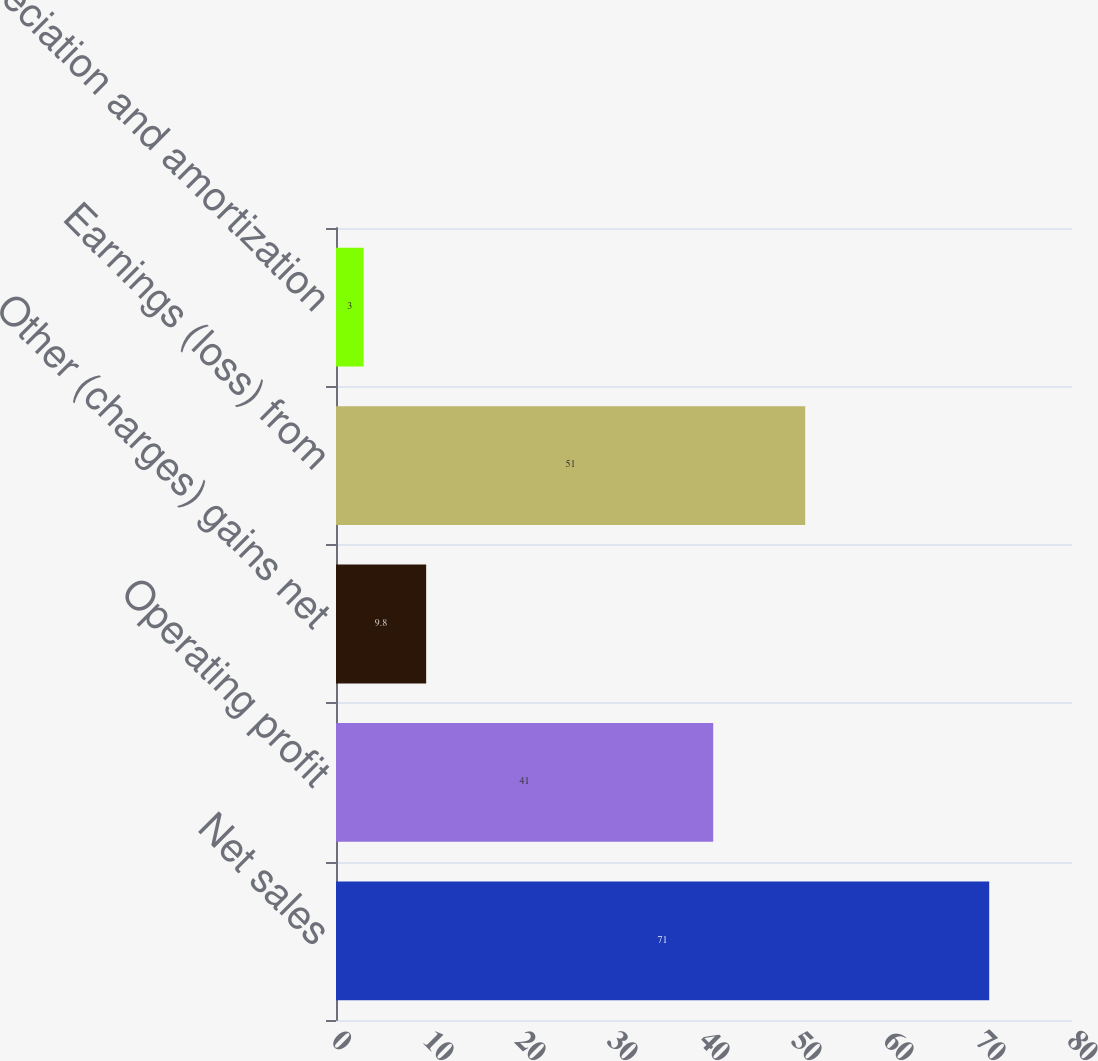Convert chart. <chart><loc_0><loc_0><loc_500><loc_500><bar_chart><fcel>Net sales<fcel>Operating profit<fcel>Other (charges) gains net<fcel>Earnings (loss) from<fcel>Depreciation and amortization<nl><fcel>71<fcel>41<fcel>9.8<fcel>51<fcel>3<nl></chart> 